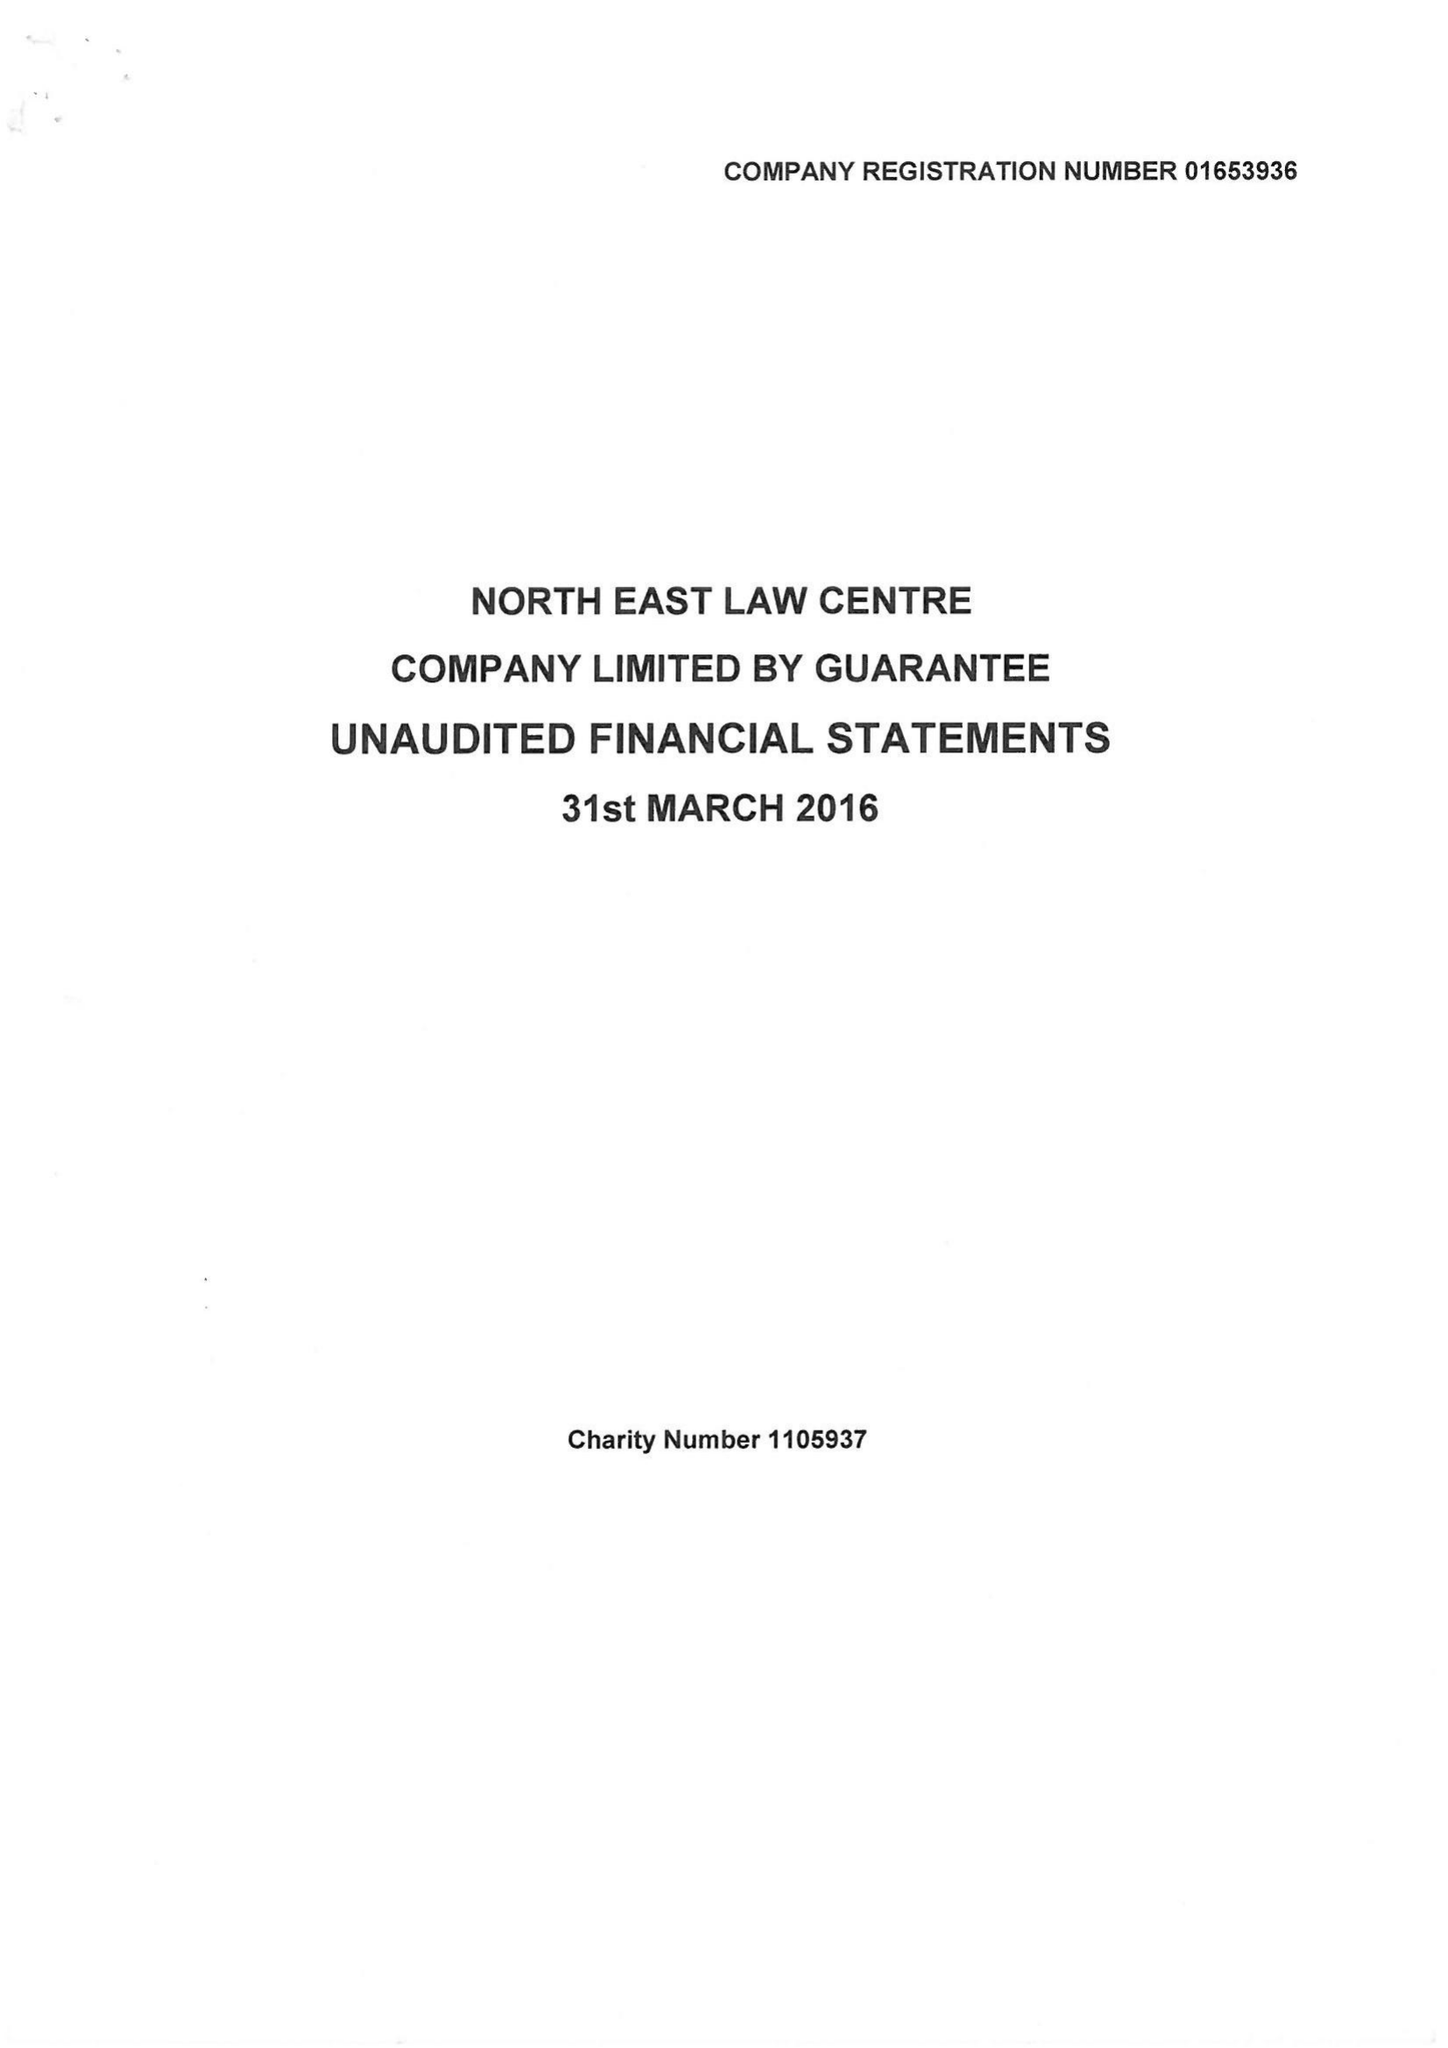What is the value for the charity_number?
Answer the question using a single word or phrase. 1105937 